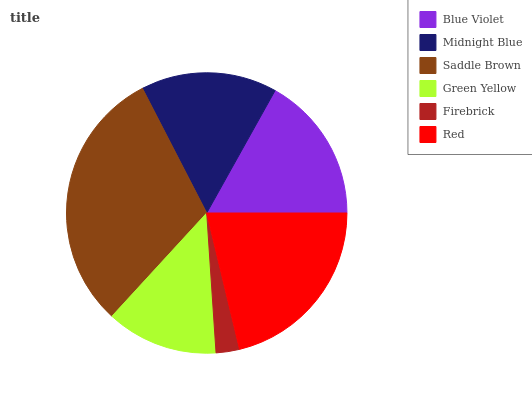Is Firebrick the minimum?
Answer yes or no. Yes. Is Saddle Brown the maximum?
Answer yes or no. Yes. Is Midnight Blue the minimum?
Answer yes or no. No. Is Midnight Blue the maximum?
Answer yes or no. No. Is Blue Violet greater than Midnight Blue?
Answer yes or no. Yes. Is Midnight Blue less than Blue Violet?
Answer yes or no. Yes. Is Midnight Blue greater than Blue Violet?
Answer yes or no. No. Is Blue Violet less than Midnight Blue?
Answer yes or no. No. Is Blue Violet the high median?
Answer yes or no. Yes. Is Midnight Blue the low median?
Answer yes or no. Yes. Is Saddle Brown the high median?
Answer yes or no. No. Is Green Yellow the low median?
Answer yes or no. No. 